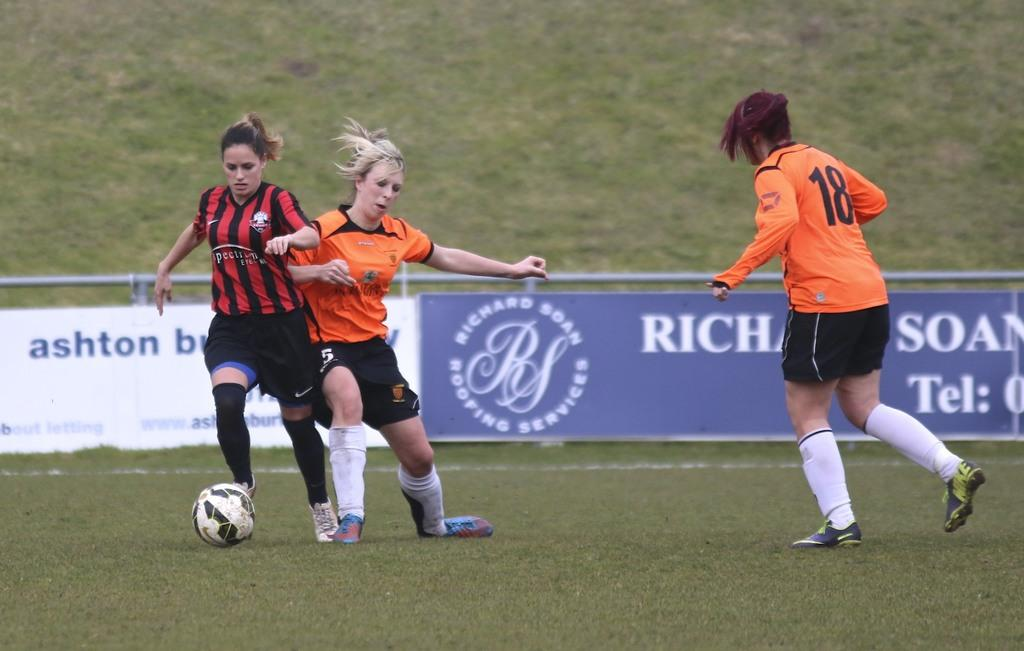What is the primary setting of the image? There is a ground in the image. What activity are the three women engaged in? The women are playing football. Can you describe the actions of the women in the image? One woman is running, and two women are playing the guitar. What type of milk is being used to test the guitar strings in the image? There is no milk or testing of guitar strings present in the image. 